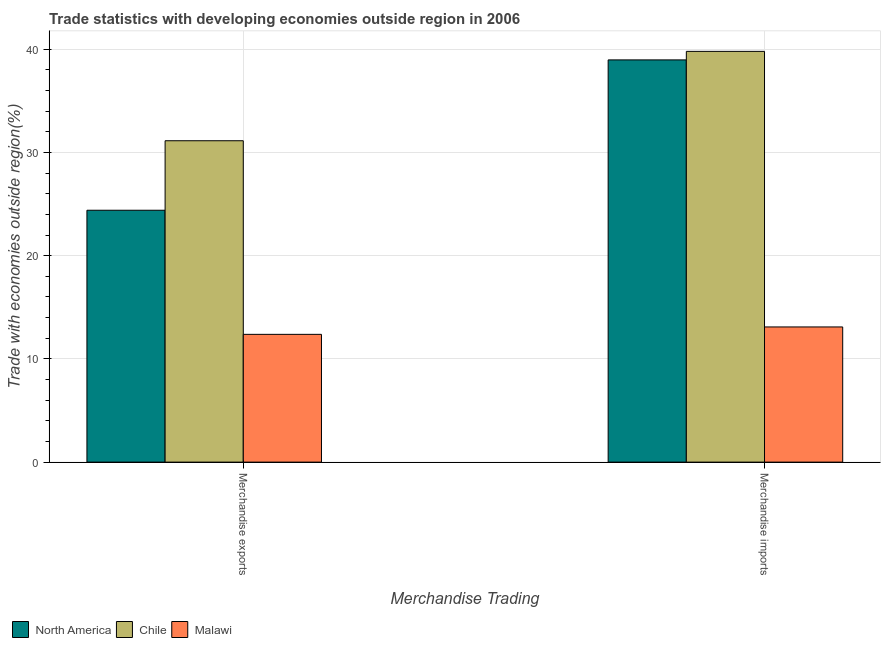Are the number of bars per tick equal to the number of legend labels?
Make the answer very short. Yes. How many bars are there on the 2nd tick from the left?
Your response must be concise. 3. What is the merchandise imports in North America?
Keep it short and to the point. 38.97. Across all countries, what is the maximum merchandise exports?
Keep it short and to the point. 31.14. Across all countries, what is the minimum merchandise imports?
Provide a short and direct response. 13.1. In which country was the merchandise exports maximum?
Ensure brevity in your answer.  Chile. In which country was the merchandise imports minimum?
Your answer should be compact. Malawi. What is the total merchandise imports in the graph?
Keep it short and to the point. 91.87. What is the difference between the merchandise imports in Chile and that in Malawi?
Give a very brief answer. 26.7. What is the difference between the merchandise imports in Chile and the merchandise exports in North America?
Your answer should be compact. 15.39. What is the average merchandise imports per country?
Give a very brief answer. 30.62. What is the difference between the merchandise imports and merchandise exports in Chile?
Give a very brief answer. 8.66. What is the ratio of the merchandise imports in Malawi to that in North America?
Offer a terse response. 0.34. Are all the bars in the graph horizontal?
Give a very brief answer. No. How many countries are there in the graph?
Your answer should be compact. 3. What is the difference between two consecutive major ticks on the Y-axis?
Your response must be concise. 10. Does the graph contain grids?
Provide a succinct answer. Yes. How are the legend labels stacked?
Keep it short and to the point. Horizontal. What is the title of the graph?
Offer a terse response. Trade statistics with developing economies outside region in 2006. What is the label or title of the X-axis?
Make the answer very short. Merchandise Trading. What is the label or title of the Y-axis?
Keep it short and to the point. Trade with economies outside region(%). What is the Trade with economies outside region(%) in North America in Merchandise exports?
Give a very brief answer. 24.4. What is the Trade with economies outside region(%) of Chile in Merchandise exports?
Ensure brevity in your answer.  31.14. What is the Trade with economies outside region(%) in Malawi in Merchandise exports?
Offer a terse response. 12.38. What is the Trade with economies outside region(%) in North America in Merchandise imports?
Provide a short and direct response. 38.97. What is the Trade with economies outside region(%) of Chile in Merchandise imports?
Your response must be concise. 39.8. What is the Trade with economies outside region(%) in Malawi in Merchandise imports?
Your response must be concise. 13.1. Across all Merchandise Trading, what is the maximum Trade with economies outside region(%) in North America?
Provide a succinct answer. 38.97. Across all Merchandise Trading, what is the maximum Trade with economies outside region(%) in Chile?
Provide a succinct answer. 39.8. Across all Merchandise Trading, what is the maximum Trade with economies outside region(%) in Malawi?
Ensure brevity in your answer.  13.1. Across all Merchandise Trading, what is the minimum Trade with economies outside region(%) in North America?
Offer a very short reply. 24.4. Across all Merchandise Trading, what is the minimum Trade with economies outside region(%) of Chile?
Provide a short and direct response. 31.14. Across all Merchandise Trading, what is the minimum Trade with economies outside region(%) of Malawi?
Provide a short and direct response. 12.38. What is the total Trade with economies outside region(%) of North America in the graph?
Your response must be concise. 63.38. What is the total Trade with economies outside region(%) in Chile in the graph?
Your response must be concise. 70.94. What is the total Trade with economies outside region(%) in Malawi in the graph?
Offer a very short reply. 25.48. What is the difference between the Trade with economies outside region(%) of North America in Merchandise exports and that in Merchandise imports?
Offer a terse response. -14.57. What is the difference between the Trade with economies outside region(%) in Chile in Merchandise exports and that in Merchandise imports?
Offer a terse response. -8.66. What is the difference between the Trade with economies outside region(%) in Malawi in Merchandise exports and that in Merchandise imports?
Provide a succinct answer. -0.72. What is the difference between the Trade with economies outside region(%) in North America in Merchandise exports and the Trade with economies outside region(%) in Chile in Merchandise imports?
Your answer should be compact. -15.39. What is the difference between the Trade with economies outside region(%) of North America in Merchandise exports and the Trade with economies outside region(%) of Malawi in Merchandise imports?
Make the answer very short. 11.31. What is the difference between the Trade with economies outside region(%) of Chile in Merchandise exports and the Trade with economies outside region(%) of Malawi in Merchandise imports?
Give a very brief answer. 18.04. What is the average Trade with economies outside region(%) of North America per Merchandise Trading?
Make the answer very short. 31.69. What is the average Trade with economies outside region(%) in Chile per Merchandise Trading?
Offer a terse response. 35.47. What is the average Trade with economies outside region(%) in Malawi per Merchandise Trading?
Your answer should be very brief. 12.74. What is the difference between the Trade with economies outside region(%) in North America and Trade with economies outside region(%) in Chile in Merchandise exports?
Your response must be concise. -6.74. What is the difference between the Trade with economies outside region(%) in North America and Trade with economies outside region(%) in Malawi in Merchandise exports?
Offer a very short reply. 12.02. What is the difference between the Trade with economies outside region(%) in Chile and Trade with economies outside region(%) in Malawi in Merchandise exports?
Offer a very short reply. 18.76. What is the difference between the Trade with economies outside region(%) of North America and Trade with economies outside region(%) of Chile in Merchandise imports?
Make the answer very short. -0.83. What is the difference between the Trade with economies outside region(%) in North America and Trade with economies outside region(%) in Malawi in Merchandise imports?
Provide a succinct answer. 25.87. What is the difference between the Trade with economies outside region(%) of Chile and Trade with economies outside region(%) of Malawi in Merchandise imports?
Make the answer very short. 26.7. What is the ratio of the Trade with economies outside region(%) of North America in Merchandise exports to that in Merchandise imports?
Provide a short and direct response. 0.63. What is the ratio of the Trade with economies outside region(%) in Chile in Merchandise exports to that in Merchandise imports?
Provide a short and direct response. 0.78. What is the ratio of the Trade with economies outside region(%) of Malawi in Merchandise exports to that in Merchandise imports?
Provide a succinct answer. 0.95. What is the difference between the highest and the second highest Trade with economies outside region(%) in North America?
Ensure brevity in your answer.  14.57. What is the difference between the highest and the second highest Trade with economies outside region(%) in Chile?
Your response must be concise. 8.66. What is the difference between the highest and the second highest Trade with economies outside region(%) in Malawi?
Offer a terse response. 0.72. What is the difference between the highest and the lowest Trade with economies outside region(%) of North America?
Give a very brief answer. 14.57. What is the difference between the highest and the lowest Trade with economies outside region(%) in Chile?
Provide a short and direct response. 8.66. What is the difference between the highest and the lowest Trade with economies outside region(%) in Malawi?
Ensure brevity in your answer.  0.72. 